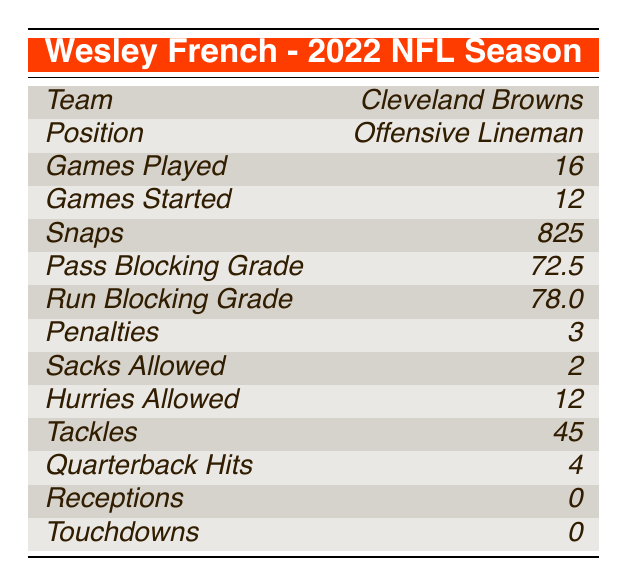What team did Wesley French play for in the 2022 NFL season? The table lists "Cleveland Browns" under the "Team" row for Wesley French.
Answer: Cleveland Browns How many games did Wesley French start in the 2022 NFL season? The table indicates that he started 12 games, as shown in the "Games Started" row.
Answer: 12 What was Wesley French's pass blocking grade? The table states that the "Pass Blocking Grade" for Wesley French is 72.5.
Answer: 72.5 How many penalties did Wesley French accumulate during the season? The "Penalties" row shows that he had a total of 3 penalties during the season.
Answer: 3 What is the total number of snaps Wesley French played? According to the "Snaps" row, he played a total of 825 snaps during the season.
Answer: 825 Did Wesley French record any receptions in the 2022 NFL season? The table indicates that Wesley French had 0 receptions under the "Receptions" row.
Answer: No What was the difference between Wesley French's run blocking grade and his pass blocking grade? The run blocking grade is 78.0, and the pass blocking grade is 72.5. The difference is 78.0 - 72.5 = 5.5.
Answer: 5.5 How many tackles did Wesley French register compared to the number of sacks allowed? Wesley French made 45 tackles and allowed 2 sacks. The ratio is 45 tackles to 2 sacks allowed, or 45/2 = 22.5 tackles per sack.
Answer: 22.5 What percentage of games did Wesley French start out of the total games played? Wesley French started 12 games out of 16 games played. The percentage can be calculated as (12/16) * 100 = 75%.
Answer: 75% How many total quarterback hits did Wesley French record compared to hurries allowed? Wesley French recorded 4 quarterback hits and allowed 12 hurries. The total is 4 hits + 12 hurries = 16 combined instances.
Answer: 16 Was his run blocking grade higher than his pass blocking grade? The run blocking grade of 78.0 is higher than the pass blocking grade of 72.5, indicating that yes, his run blocking grade is higher.
Answer: Yes 